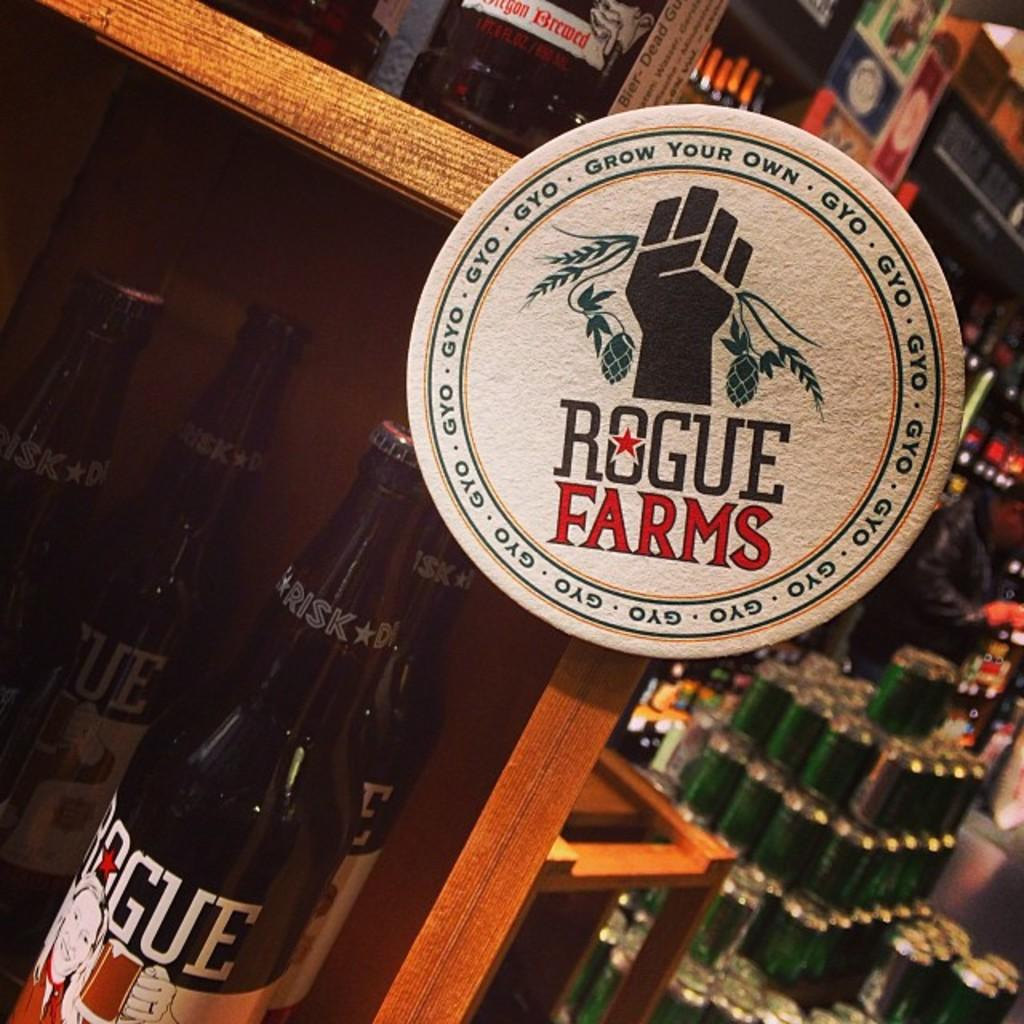<image>
Describe the image concisely. A bottle is on a shelf with a logo for Rogue Farms above it. 